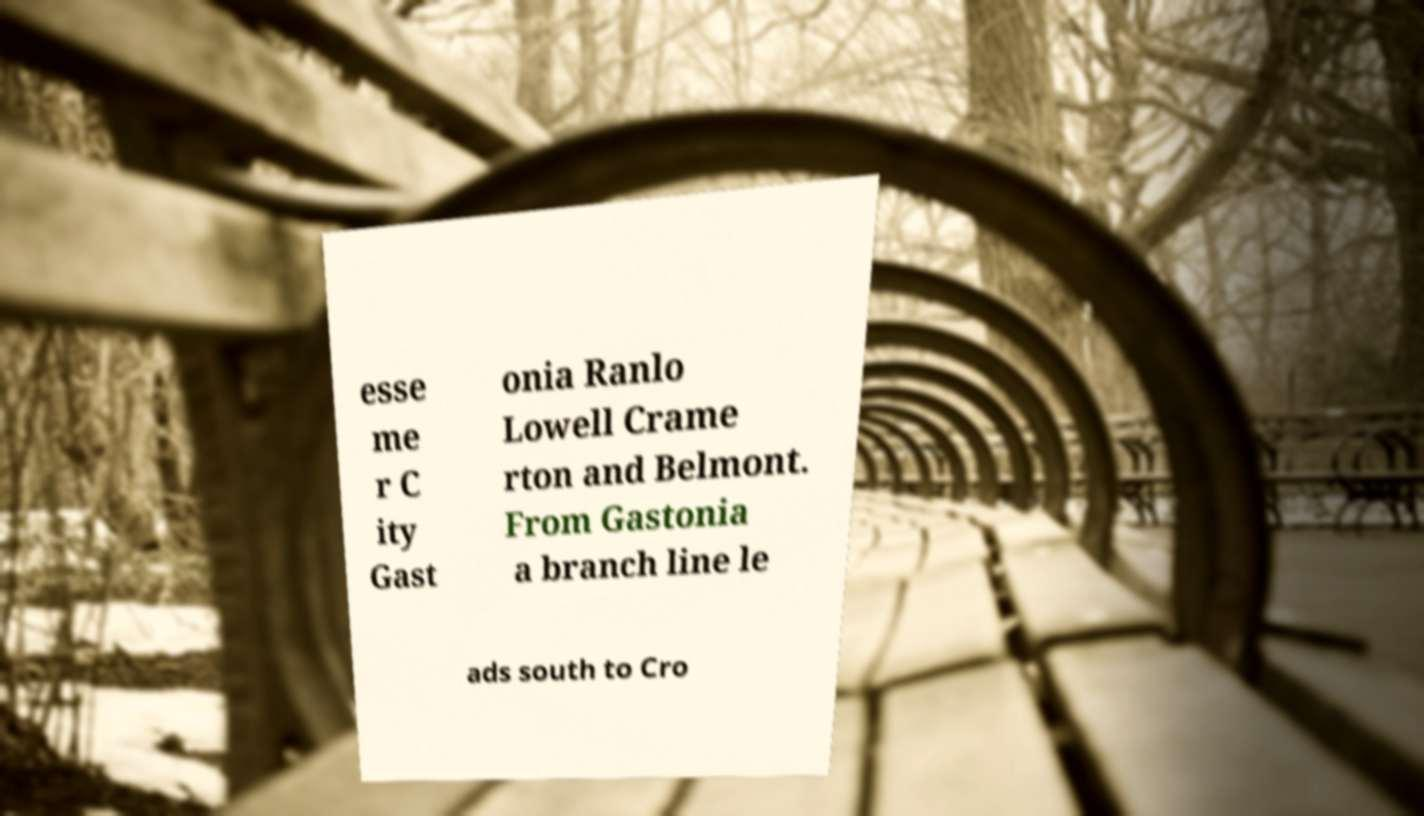Can you read and provide the text displayed in the image?This photo seems to have some interesting text. Can you extract and type it out for me? esse me r C ity Gast onia Ranlo Lowell Crame rton and Belmont. From Gastonia a branch line le ads south to Cro 